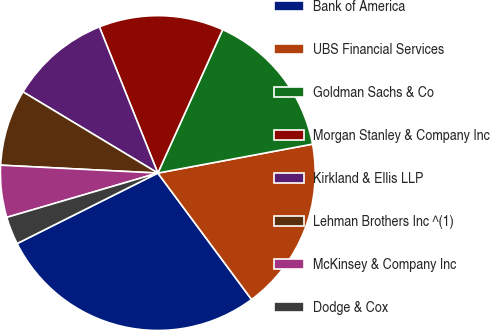<chart> <loc_0><loc_0><loc_500><loc_500><pie_chart><fcel>Bank of America<fcel>UBS Financial Services<fcel>Goldman Sachs & Co<fcel>Morgan Stanley & Company Inc<fcel>Kirkland & Ellis LLP<fcel>Lehman Brothers Inc ^(1)<fcel>McKinsey & Company Inc<fcel>Dodge & Cox<nl><fcel>27.76%<fcel>17.79%<fcel>15.3%<fcel>12.81%<fcel>10.32%<fcel>7.83%<fcel>5.34%<fcel>2.85%<nl></chart> 